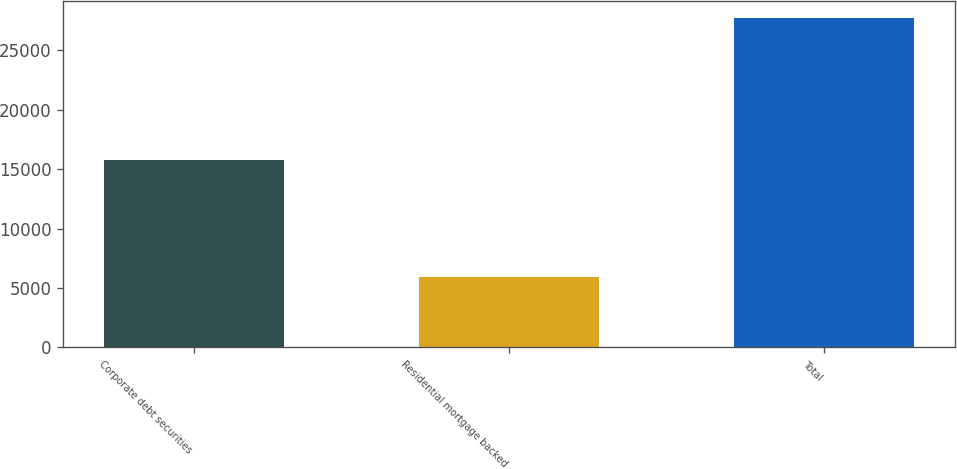<chart> <loc_0><loc_0><loc_500><loc_500><bar_chart><fcel>Corporate debt securities<fcel>Residential mortgage backed<fcel>Total<nl><fcel>15750<fcel>5933<fcel>27752<nl></chart> 